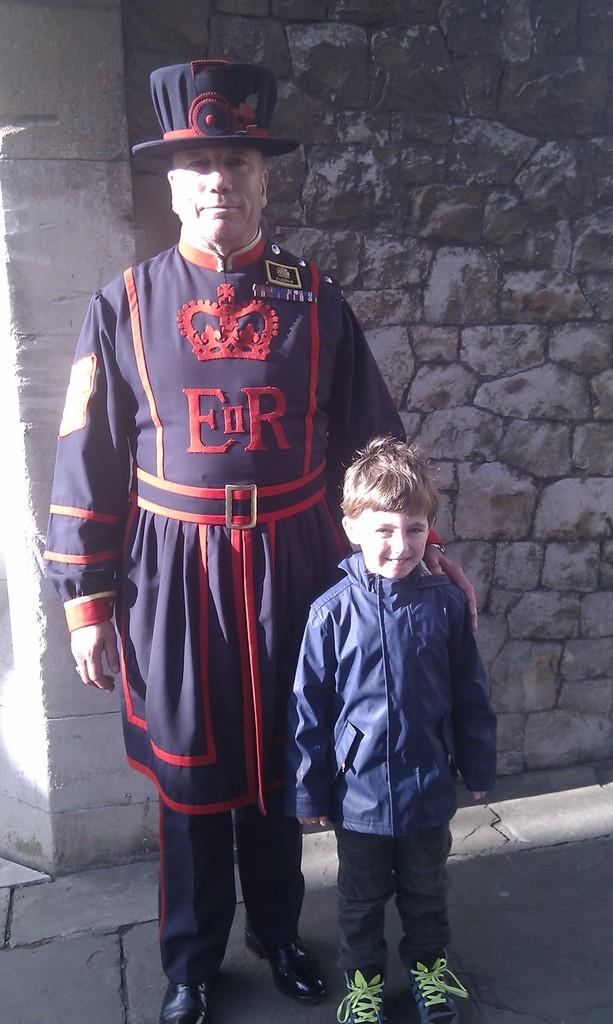In one or two sentences, can you explain what this image depicts? In this image in the center there is one man and one boy standing and in the background there is wall, at the bottom there is a walkway. 